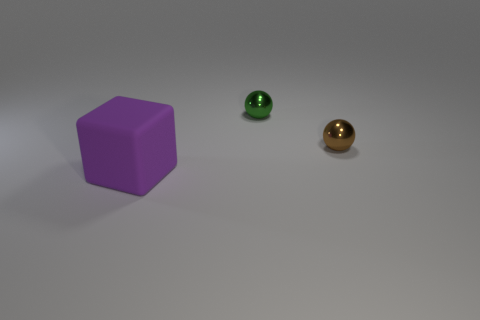How many objects are shiny balls that are right of the small green object or big green metallic cylinders?
Your answer should be compact. 1. There is a object that is the same size as the green sphere; what is it made of?
Provide a succinct answer. Metal. There is a small object that is in front of the metallic object to the left of the brown shiny object; what color is it?
Make the answer very short. Brown. There is a large block; how many green metal spheres are to the left of it?
Offer a terse response. 0. What is the color of the cube?
Your answer should be compact. Purple. How many small objects are brown things or purple objects?
Your answer should be very brief. 1. Do the small sphere that is left of the tiny brown metal sphere and the small sphere to the right of the small green object have the same color?
Offer a terse response. No. What shape is the metal object that is left of the brown object?
Make the answer very short. Sphere. Are there fewer large red balls than green things?
Your answer should be very brief. Yes. Is the material of the small sphere that is in front of the tiny green metal thing the same as the cube?
Your answer should be very brief. No. 